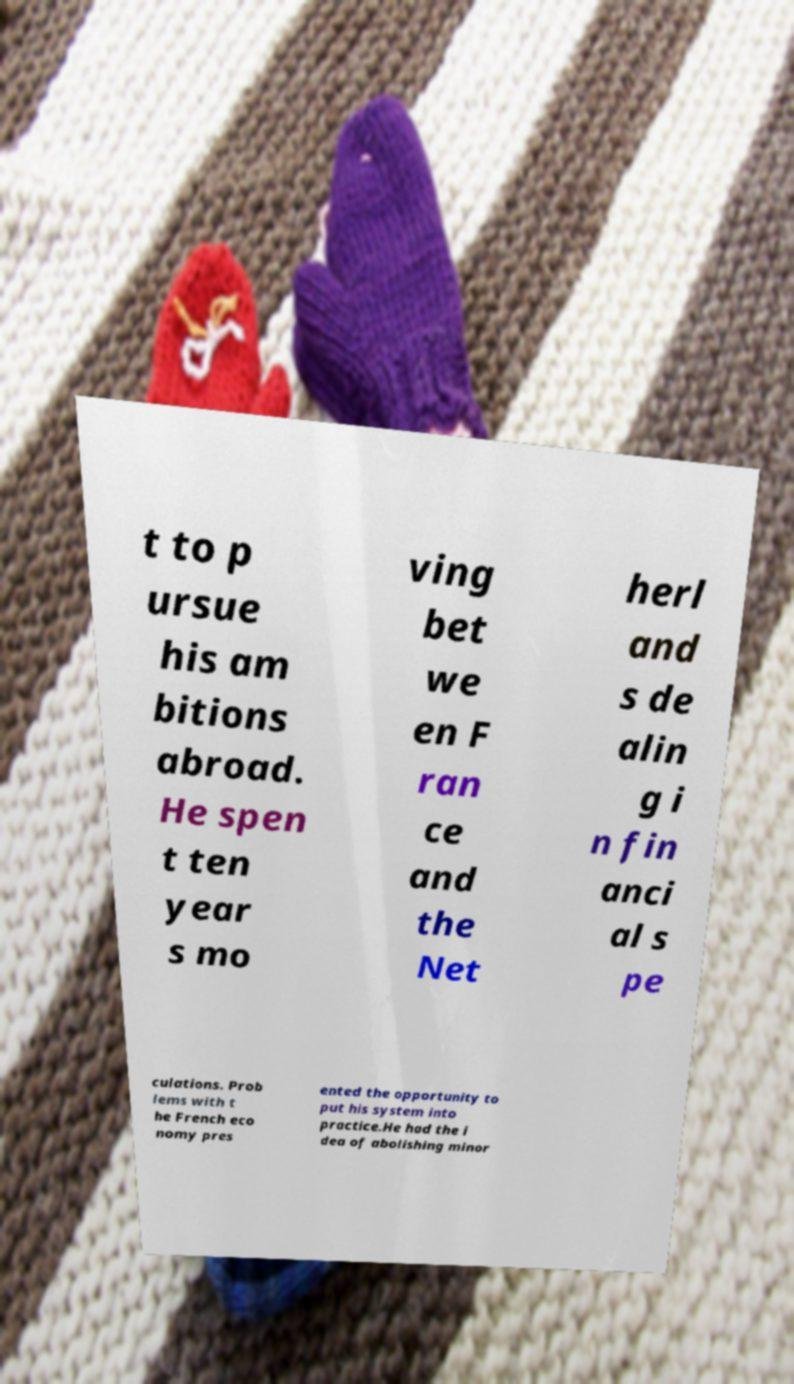Can you read and provide the text displayed in the image?This photo seems to have some interesting text. Can you extract and type it out for me? t to p ursue his am bitions abroad. He spen t ten year s mo ving bet we en F ran ce and the Net herl and s de alin g i n fin anci al s pe culations. Prob lems with t he French eco nomy pres ented the opportunity to put his system into practice.He had the i dea of abolishing minor 